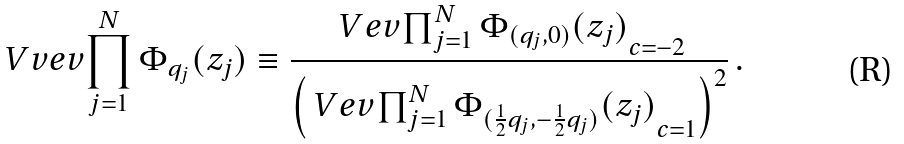<formula> <loc_0><loc_0><loc_500><loc_500>\ V v e v { \prod _ { j = 1 } ^ { N } \Phi _ { q _ { j } } ( z _ { j } ) } \equiv \frac { \ V e v { \prod _ { j = 1 } ^ { N } \Phi _ { ( q _ { j } , 0 ) } ( z _ { j } ) } _ { c = - 2 } } { \left ( \ V e v { \prod _ { j = 1 } ^ { N } \Phi _ { ( \frac { 1 } { 2 } q _ { j } , - \frac { 1 } { 2 } q _ { j } ) } ( z _ { j } ) } _ { c = 1 } \right ) ^ { 2 } } \, .</formula> 